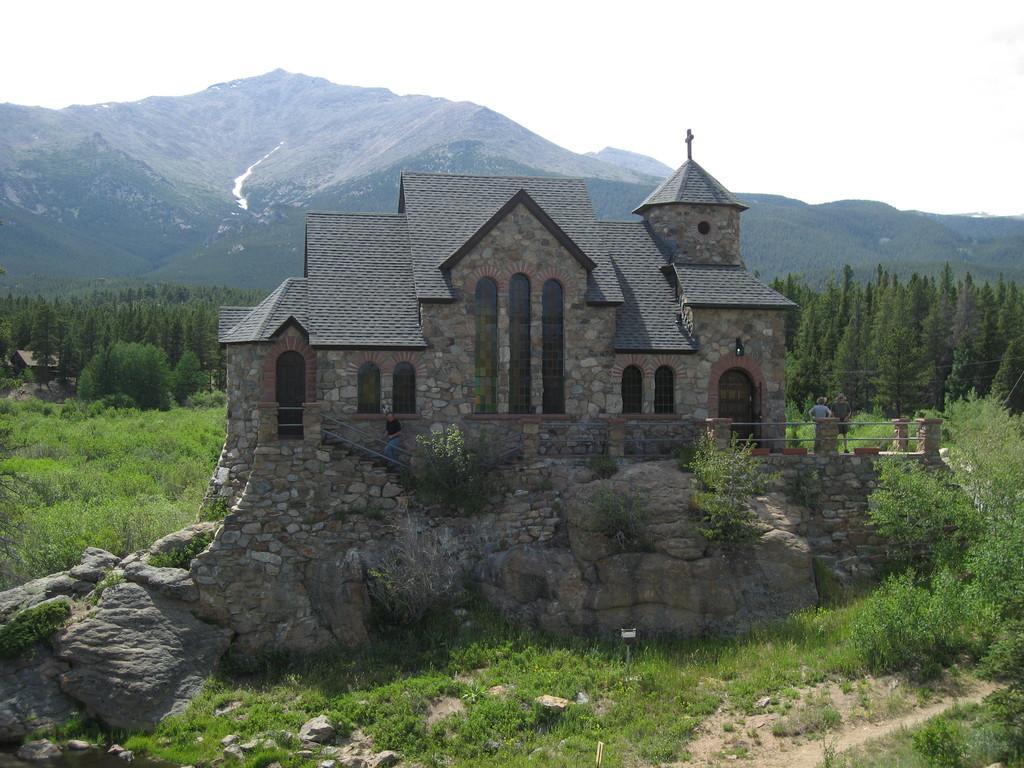In one or two sentences, can you explain what this image depicts? This image consists of a house. At the bottom, there are rocks and green grass. On the left and right, we can see plants and trees. In the background, there is a mountain. At the top, there is sky. 